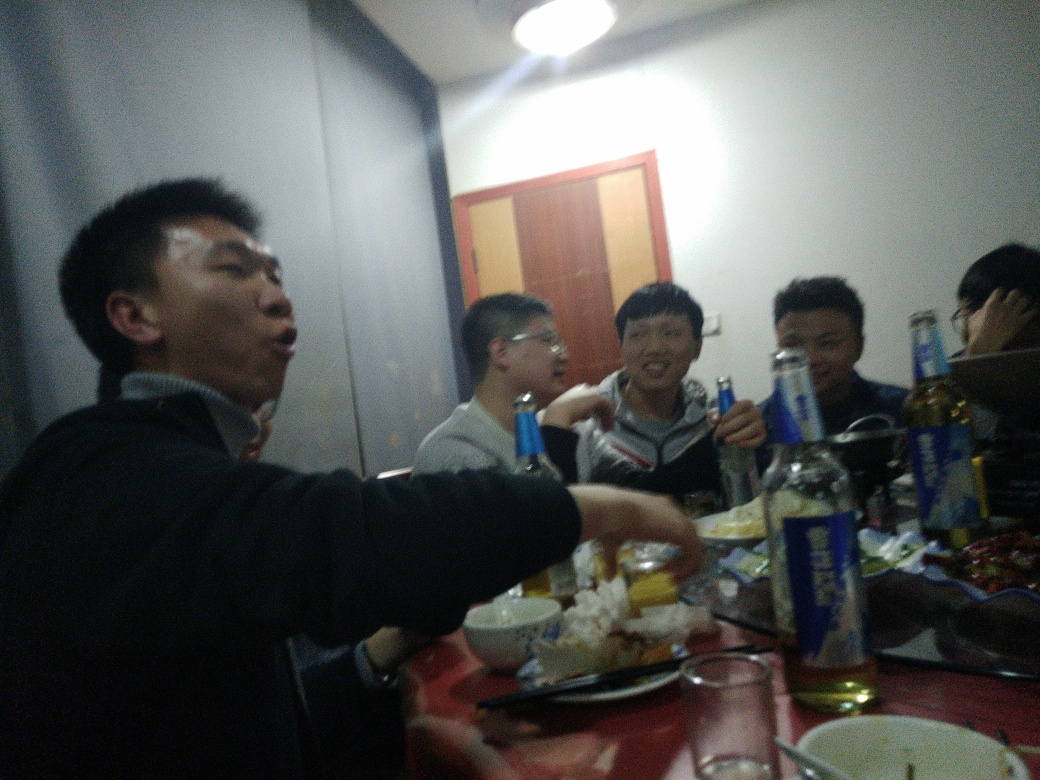Why is the quality of this image poor?
A. High clarity, rich texture details, no noise, high contrast, vibrant colors
B. Medium clarity, some texture details, minimal noise, moderate contrast, pleasant colors
C. Slightly low clarity, minor texture loss, little noise, decent contrast, satisfactory colors
D. Overall low clarity, loss of fine texture details, significant noise, low contrast, unremarkable colors
Answer with the option's letter from the given choices directly.
 D. 